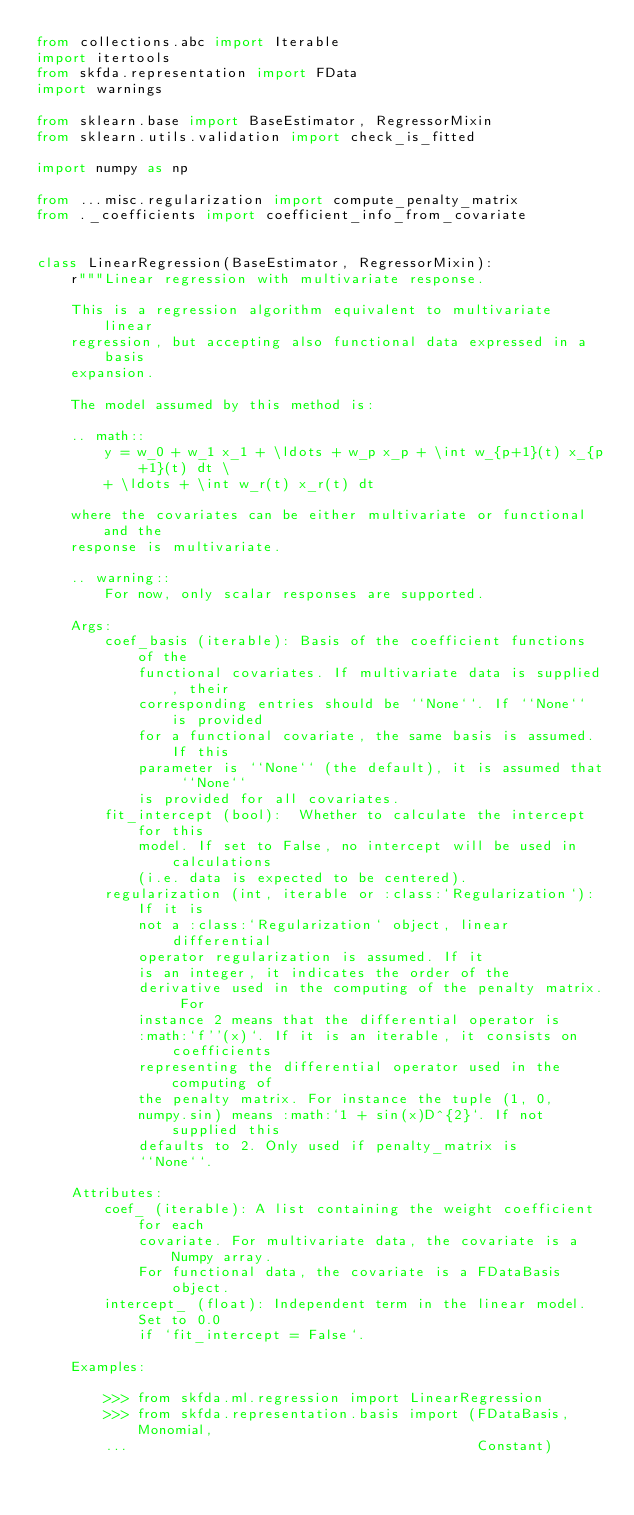<code> <loc_0><loc_0><loc_500><loc_500><_Python_>from collections.abc import Iterable
import itertools
from skfda.representation import FData
import warnings

from sklearn.base import BaseEstimator, RegressorMixin
from sklearn.utils.validation import check_is_fitted

import numpy as np

from ...misc.regularization import compute_penalty_matrix
from ._coefficients import coefficient_info_from_covariate


class LinearRegression(BaseEstimator, RegressorMixin):
    r"""Linear regression with multivariate response.

    This is a regression algorithm equivalent to multivariate linear
    regression, but accepting also functional data expressed in a basis
    expansion.

    The model assumed by this method is:

    .. math::
        y = w_0 + w_1 x_1 + \ldots + w_p x_p + \int w_{p+1}(t) x_{p+1}(t) dt \
        + \ldots + \int w_r(t) x_r(t) dt

    where the covariates can be either multivariate or functional and the
    response is multivariate.

    .. warning::
        For now, only scalar responses are supported.

    Args:
        coef_basis (iterable): Basis of the coefficient functions of the
            functional covariates. If multivariate data is supplied, their
            corresponding entries should be ``None``. If ``None`` is provided
            for a functional covariate, the same basis is assumed. If this
            parameter is ``None`` (the default), it is assumed that ``None``
            is provided for all covariates.
        fit_intercept (bool):  Whether to calculate the intercept for this
            model. If set to False, no intercept will be used in calculations
            (i.e. data is expected to be centered).
        regularization (int, iterable or :class:`Regularization`): If it is
            not a :class:`Regularization` object, linear differential
            operator regularization is assumed. If it
            is an integer, it indicates the order of the
            derivative used in the computing of the penalty matrix. For
            instance 2 means that the differential operator is
            :math:`f''(x)`. If it is an iterable, it consists on coefficients
            representing the differential operator used in the computing of
            the penalty matrix. For instance the tuple (1, 0,
            numpy.sin) means :math:`1 + sin(x)D^{2}`. If not supplied this
            defaults to 2. Only used if penalty_matrix is
            ``None``.

    Attributes:
        coef_ (iterable): A list containing the weight coefficient for each
            covariate. For multivariate data, the covariate is a Numpy array.
            For functional data, the covariate is a FDataBasis object.
        intercept_ (float): Independent term in the linear model. Set to 0.0
            if `fit_intercept = False`.

    Examples:

        >>> from skfda.ml.regression import LinearRegression
        >>> from skfda.representation.basis import (FDataBasis, Monomial,
        ...                                         Constant)
</code> 